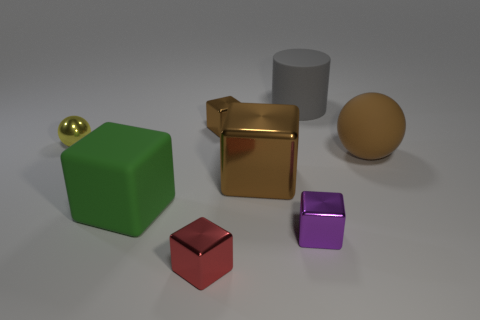What is the color of the rubber block? green 